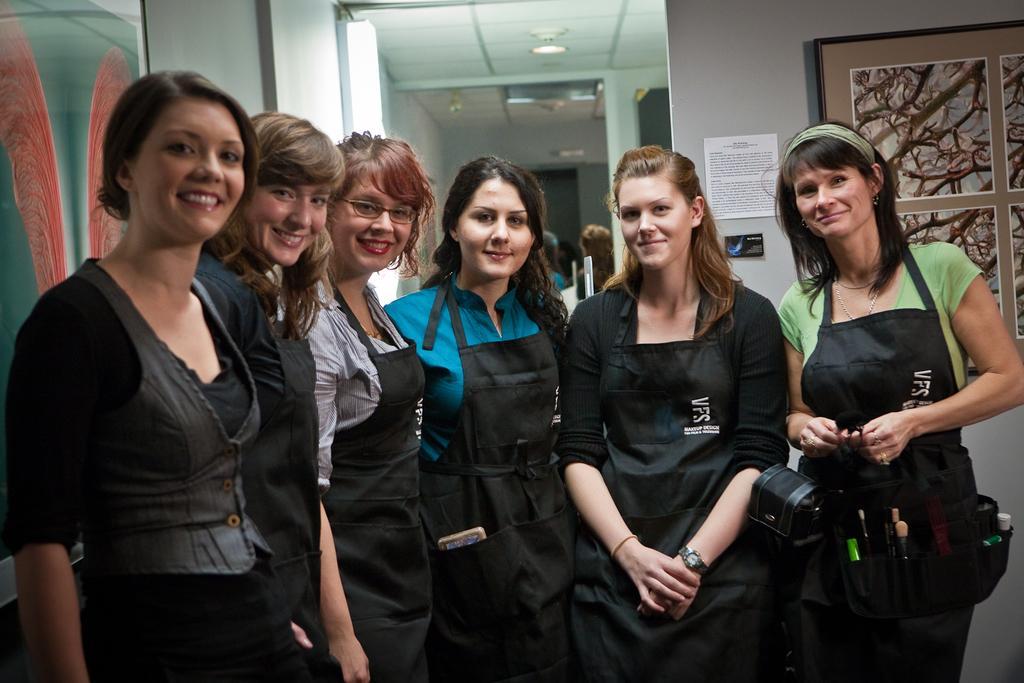How would you summarize this image in a sentence or two? In the picture we can see five women are standing together and smiling and behind them, we can see a part of the wall with a note and beside it, we can see the photo frame with some designs on it and to the ceiling we can see the light. 